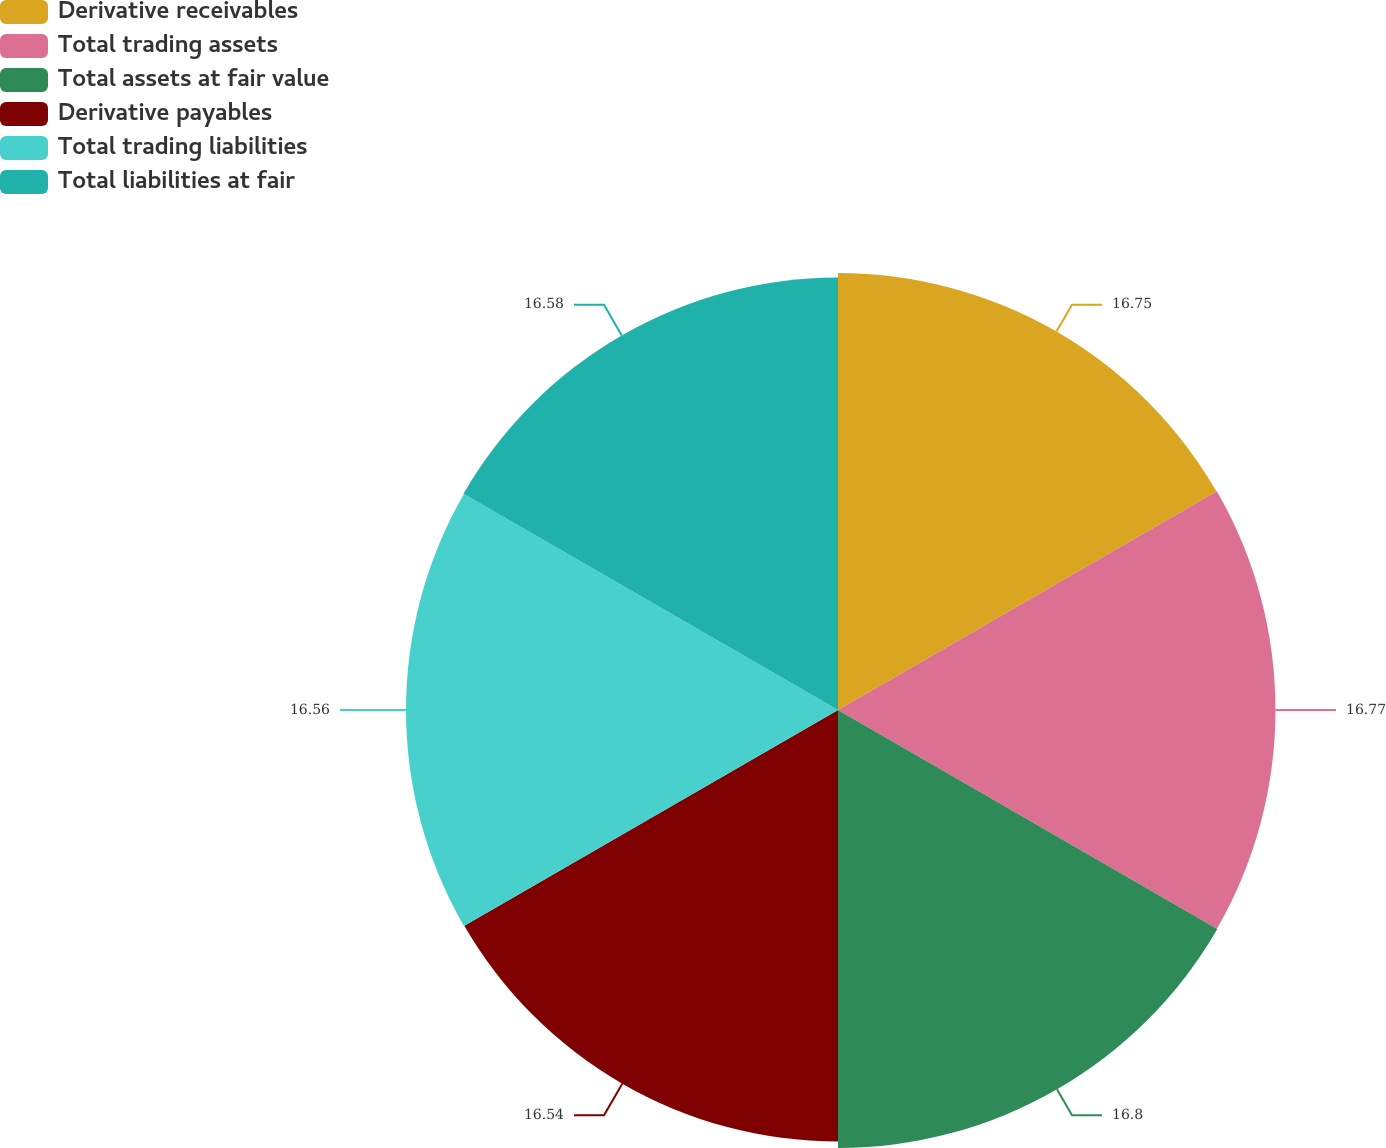<chart> <loc_0><loc_0><loc_500><loc_500><pie_chart><fcel>Derivative receivables<fcel>Total trading assets<fcel>Total assets at fair value<fcel>Derivative payables<fcel>Total trading liabilities<fcel>Total liabilities at fair<nl><fcel>16.75%<fcel>16.77%<fcel>16.79%<fcel>16.54%<fcel>16.56%<fcel>16.58%<nl></chart> 